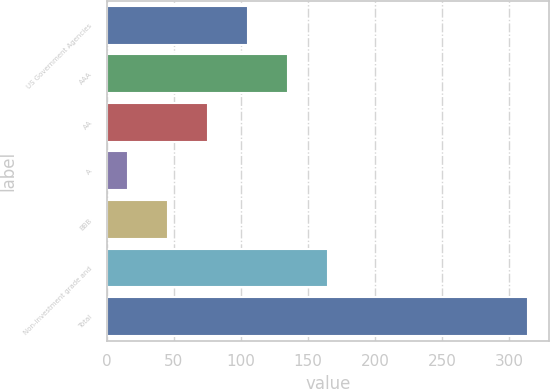Convert chart to OTSL. <chart><loc_0><loc_0><loc_500><loc_500><bar_chart><fcel>US Government Agencies<fcel>AAA<fcel>AA<fcel>A<fcel>BBB<fcel>Non-investment grade and<fcel>Total<nl><fcel>105.4<fcel>135.2<fcel>75.6<fcel>16<fcel>45.8<fcel>165<fcel>314<nl></chart> 